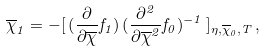Convert formula to latex. <formula><loc_0><loc_0><loc_500><loc_500>\overline { \chi } _ { 1 } = - [ \, ( \frac { \partial } { \partial \overline { \chi } } f _ { 1 } ) \, ( \frac { \partial ^ { 2 } } { \partial \overline { \chi } ^ { 2 } } f _ { 0 } ) ^ { - 1 } \, ] _ { \eta , \overline { \chi } _ { 0 } , T } \, ,</formula> 